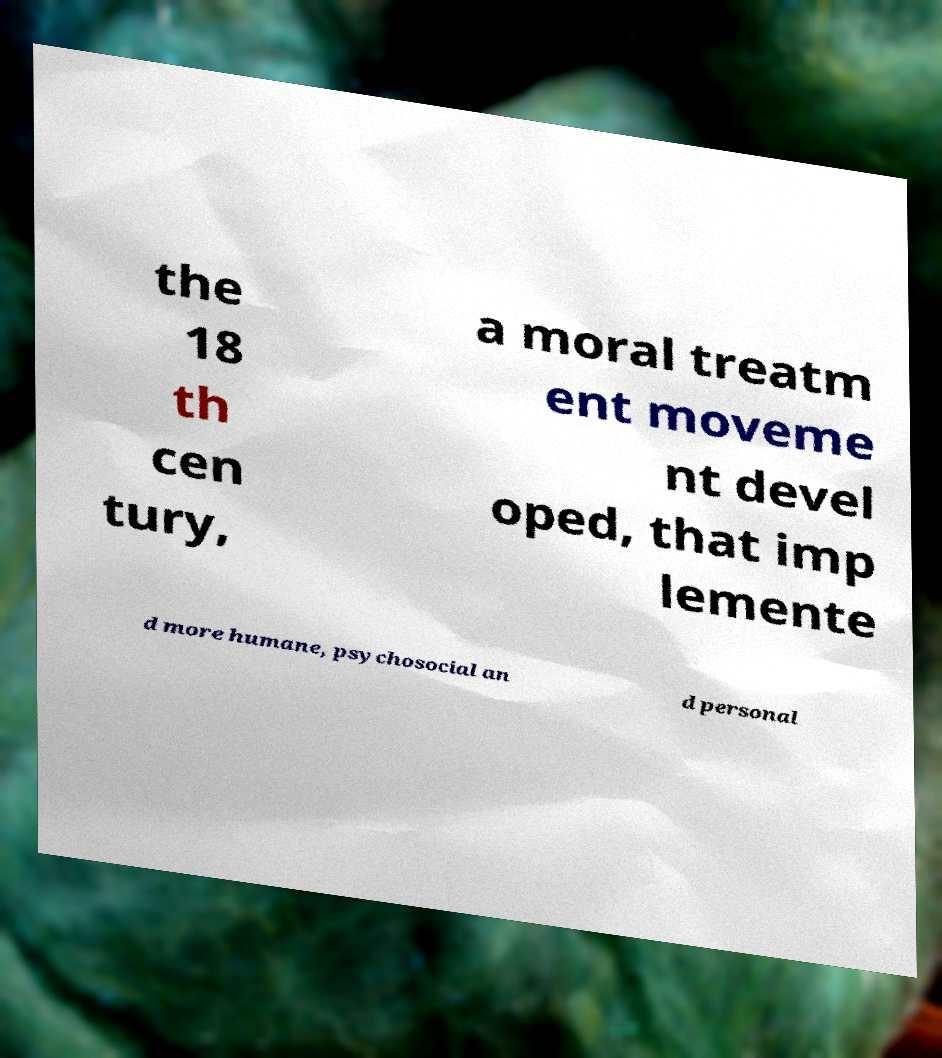Could you assist in decoding the text presented in this image and type it out clearly? the 18 th cen tury, a moral treatm ent moveme nt devel oped, that imp lemente d more humane, psychosocial an d personal 